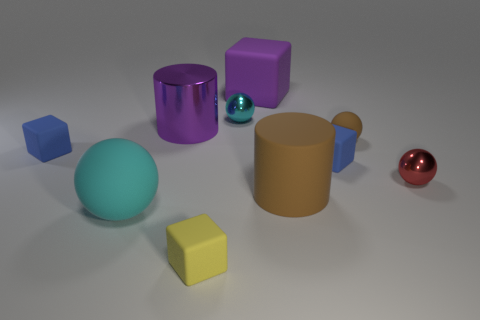There is a cyan matte thing; are there any large brown things to the left of it?
Ensure brevity in your answer.  No. What number of shiny objects are either yellow cubes or big blue blocks?
Offer a very short reply. 0. There is a tiny yellow matte thing; how many rubber cubes are behind it?
Offer a terse response. 3. Are there any brown shiny cylinders of the same size as the purple shiny cylinder?
Offer a very short reply. No. Are there any other shiny blocks of the same color as the big cube?
Make the answer very short. No. Is there any other thing that has the same size as the purple cylinder?
Offer a very short reply. Yes. What number of big matte blocks have the same color as the metal cylinder?
Your answer should be very brief. 1. Does the rubber cylinder have the same color as the ball on the right side of the tiny rubber sphere?
Offer a very short reply. No. How many objects are either purple matte things or cubes behind the large ball?
Offer a very short reply. 3. How big is the blue rubber thing that is left of the sphere on the left side of the small yellow block?
Your answer should be compact. Small. 